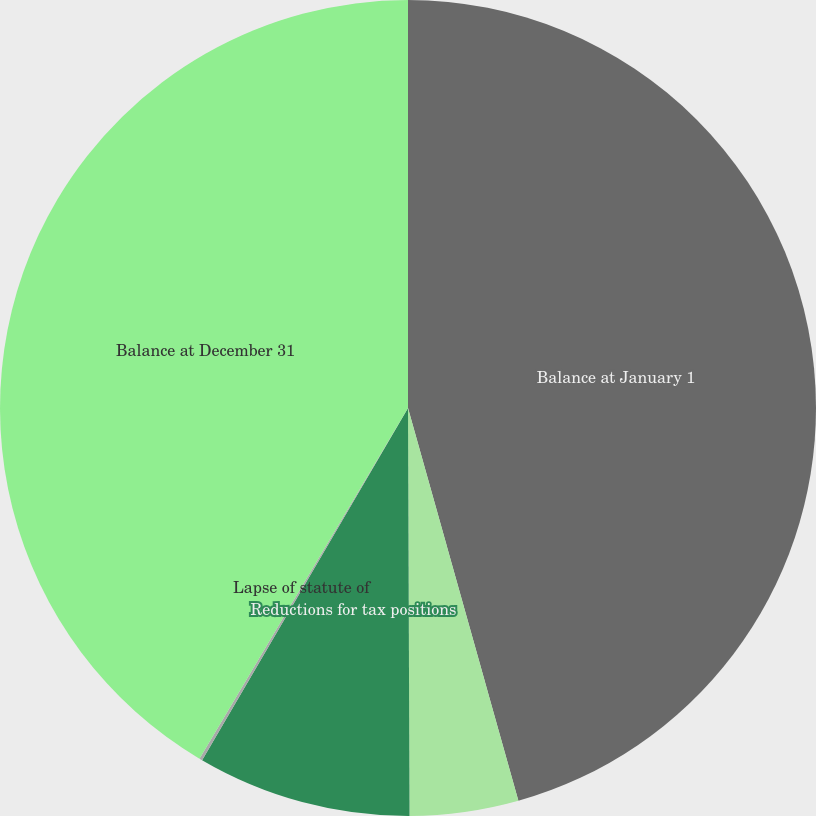<chart> <loc_0><loc_0><loc_500><loc_500><pie_chart><fcel>Balance at January 1<fcel>Additions for tax positions of<fcel>Reductions for tax positions<fcel>Lapse of statute of<fcel>Balance at December 31<nl><fcel>45.64%<fcel>4.3%<fcel>8.48%<fcel>0.12%<fcel>41.46%<nl></chart> 